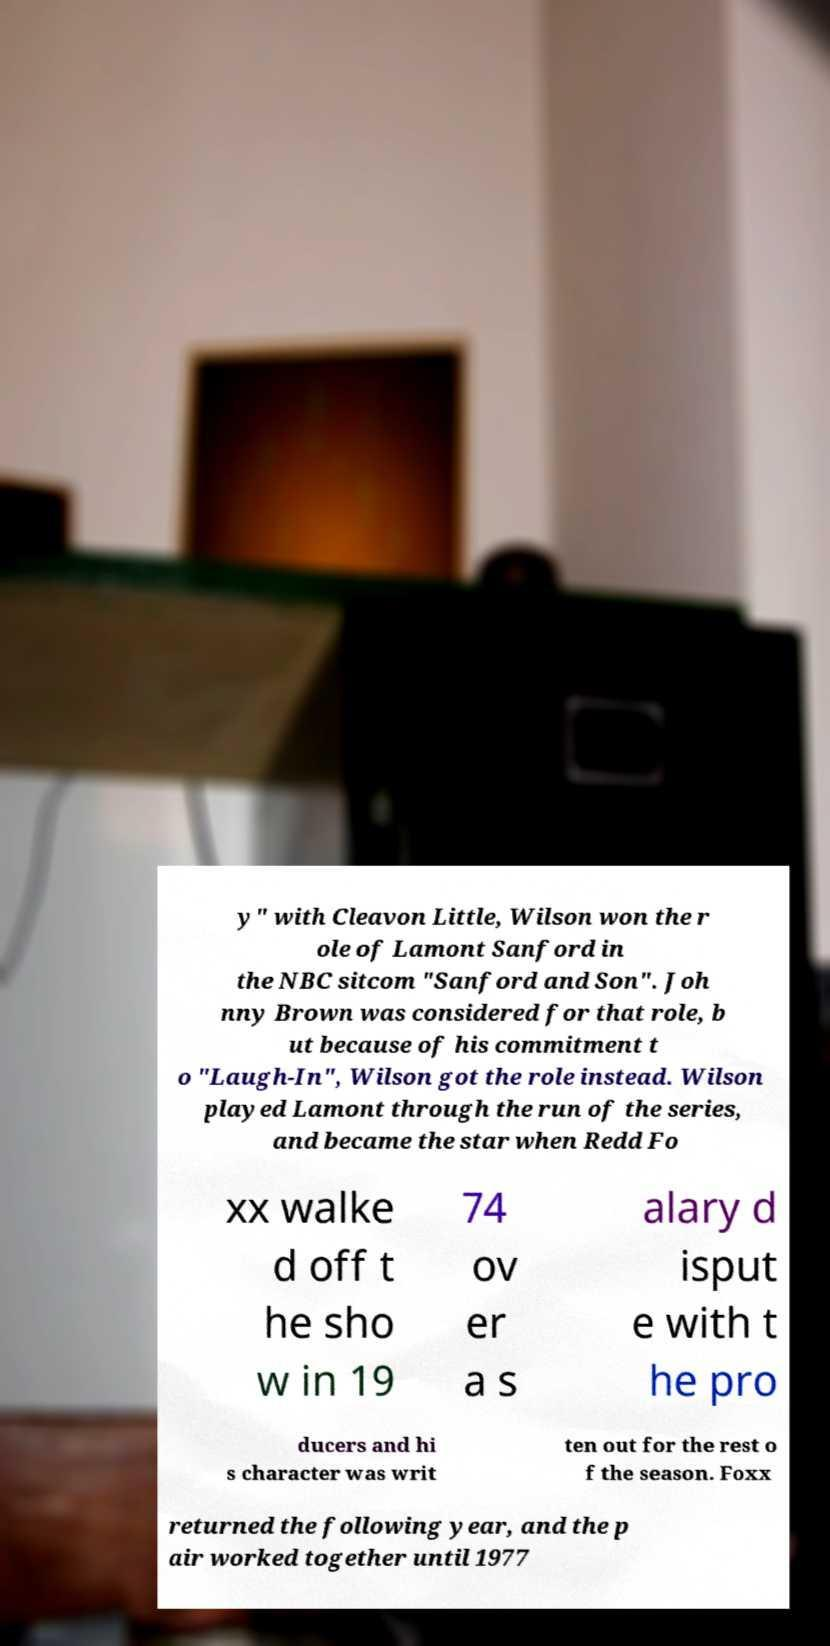For documentation purposes, I need the text within this image transcribed. Could you provide that? y" with Cleavon Little, Wilson won the r ole of Lamont Sanford in the NBC sitcom "Sanford and Son". Joh nny Brown was considered for that role, b ut because of his commitment t o "Laugh-In", Wilson got the role instead. Wilson played Lamont through the run of the series, and became the star when Redd Fo xx walke d off t he sho w in 19 74 ov er a s alary d isput e with t he pro ducers and hi s character was writ ten out for the rest o f the season. Foxx returned the following year, and the p air worked together until 1977 